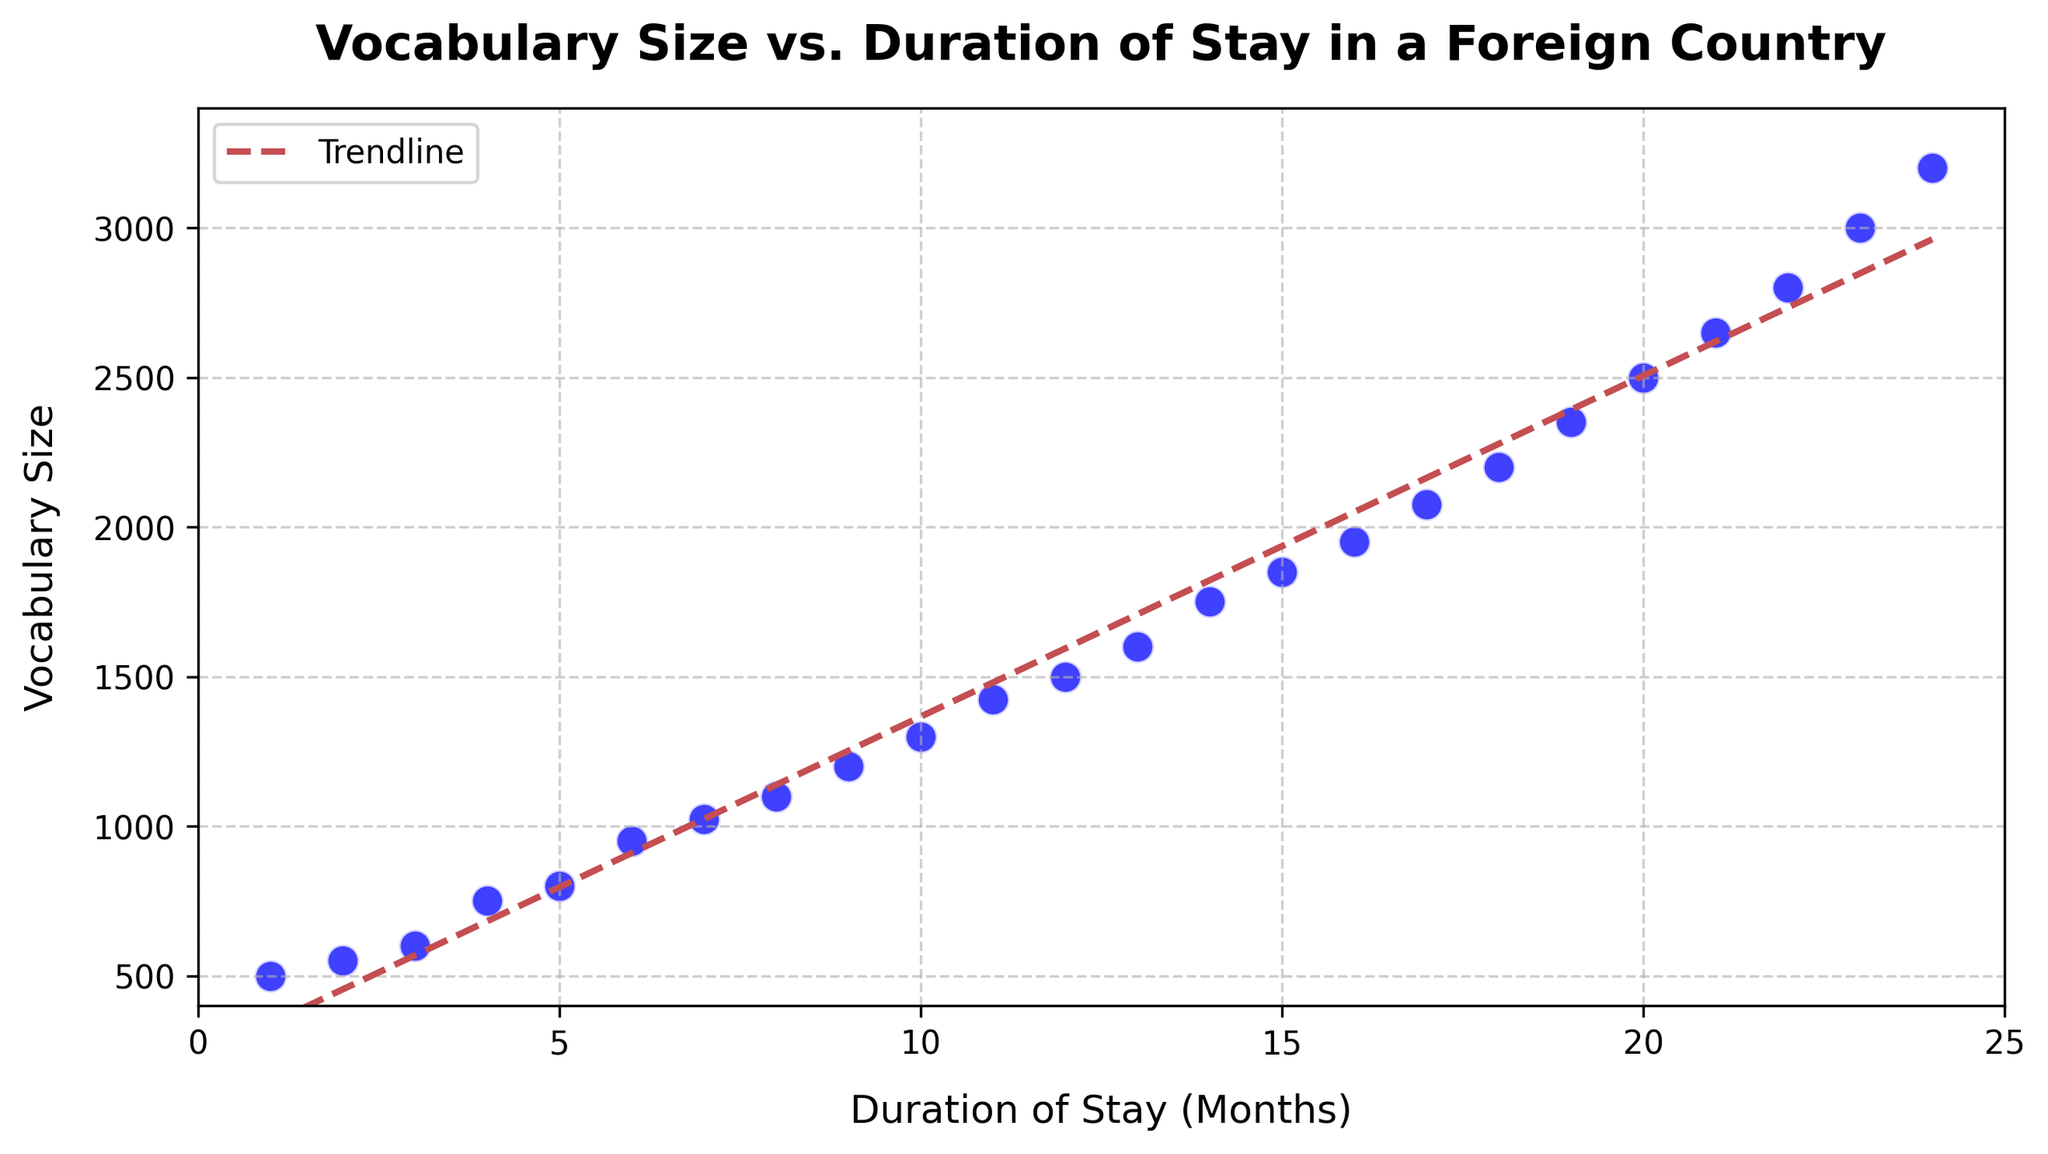What's the vocabulary size after staying for 10 months? Refer to the point on the scatter plot where the Duration of Stay is 10 months. The corresponding Vocabulary Size is the y-coordinate of this point, which is 1300.
Answer: 1300 How does the vocabulary size change from month 5 to month 10? Find the Vocabulary Size at 5 months (800) and at 10 months (1300). The change is 1300 - 800 = 500.
Answer: 500 Is the increase in vocabulary size consistent over the duration of stay? Observe the trend line and the scatter points. The trend line is roughly linear, indicating a consistent increase in vocabulary size over time.
Answer: Yes Which month shows the first vocabulary size above 2000? Find the first point where the Vocabulary Size exceeds 2000. This happens at around 17 months (Vocabulary Size = 2075).
Answer: 17 Is there any period where the vocabulary size growth rate decreases? By inspecting the scatter plot and the trend line, it appears that the data points deviate from a strict linear increase between 20 and 24 months, suggesting a lower growth rate during this period.
Answer: Yes What is the average vocabulary size for stays from 1 to 10 months? Calculate the sum of Vocabulary Sizes for months 1 through 10 and divide by 10: (500 + 550 + 600 + 750 + 800 + 950 + 1025 + 1100 + 1200 + 1300) / 10 = 8775 / 10 = 877.5
Answer: 877.5 What color are the scatter points in the plot? Observe the visual attributes in the plot. The scatter points are colored blue.
Answer: Blue Which month corresponds to the highest vocabulary size? Identify the scatter point with the maximum y-coordinate. Vocabulary Size is highest at 24 months (3200).
Answer: 24 Is there a trendline shown in the plot, and how is it visually represented? Yes, there is a trendline in the plot. It is represented by a red dashed line.
Answer: Yes, red dashed line How many months of stay does it take to reach a vocabulary size of approximately 1500? Locate the point where Vocabulary Size is around 1500. This corresponds to approximately 12 months.
Answer: 12 